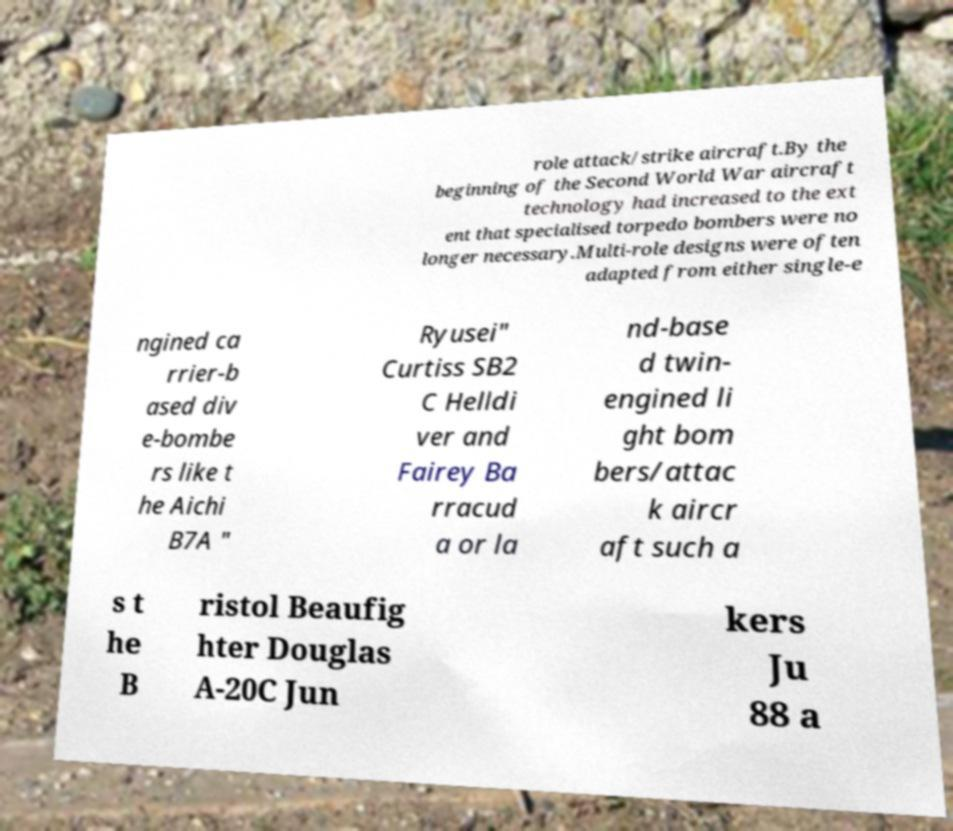Can you read and provide the text displayed in the image?This photo seems to have some interesting text. Can you extract and type it out for me? role attack/strike aircraft.By the beginning of the Second World War aircraft technology had increased to the ext ent that specialised torpedo bombers were no longer necessary.Multi-role designs were often adapted from either single-e ngined ca rrier-b ased div e-bombe rs like t he Aichi B7A " Ryusei" Curtiss SB2 C Helldi ver and Fairey Ba rracud a or la nd-base d twin- engined li ght bom bers/attac k aircr aft such a s t he B ristol Beaufig hter Douglas A-20C Jun kers Ju 88 a 